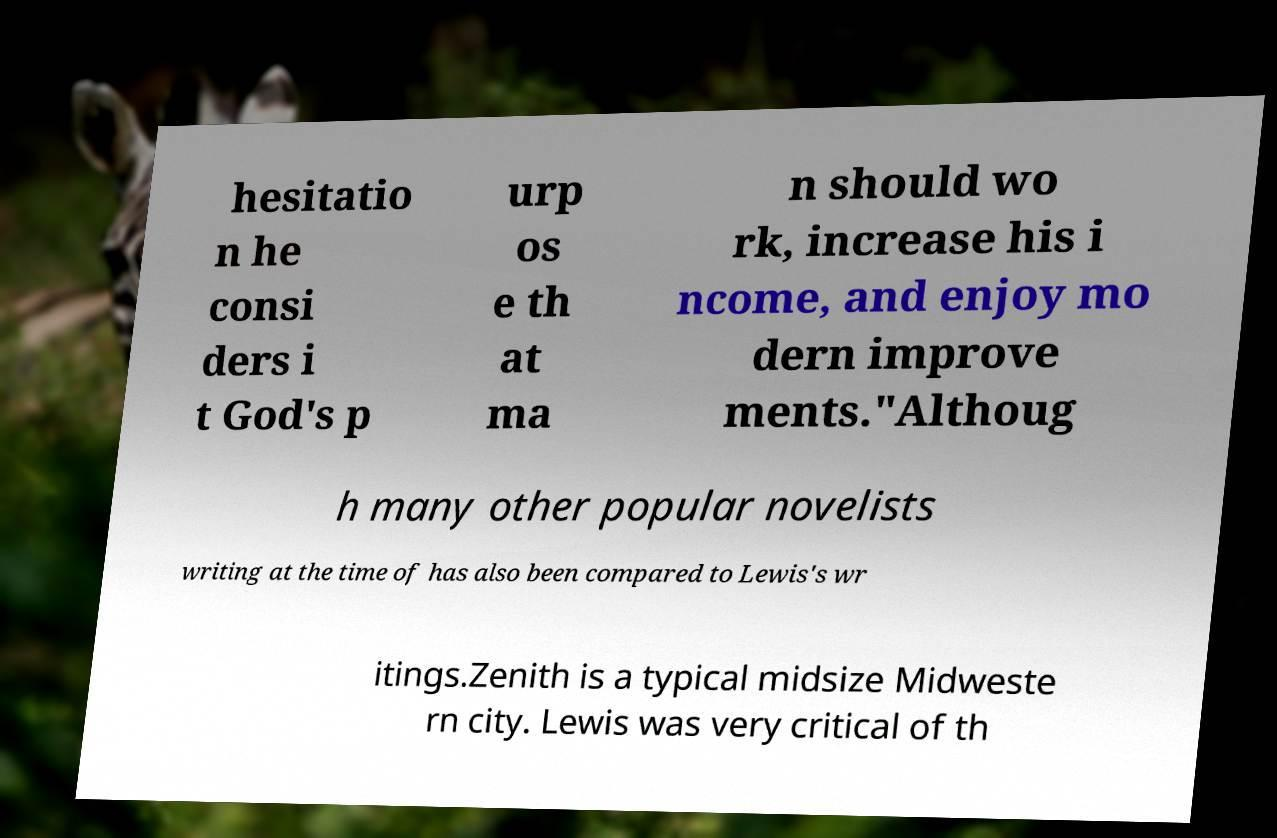Can you read and provide the text displayed in the image?This photo seems to have some interesting text. Can you extract and type it out for me? hesitatio n he consi ders i t God's p urp os e th at ma n should wo rk, increase his i ncome, and enjoy mo dern improve ments."Althoug h many other popular novelists writing at the time of has also been compared to Lewis's wr itings.Zenith is a typical midsize Midweste rn city. Lewis was very critical of th 